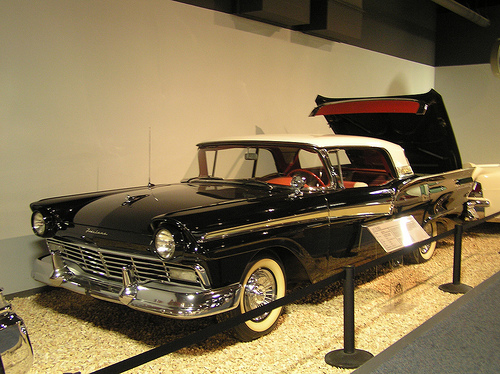<image>
Is the white car in front of the black car? No. The white car is not in front of the black car. The spatial positioning shows a different relationship between these objects. 